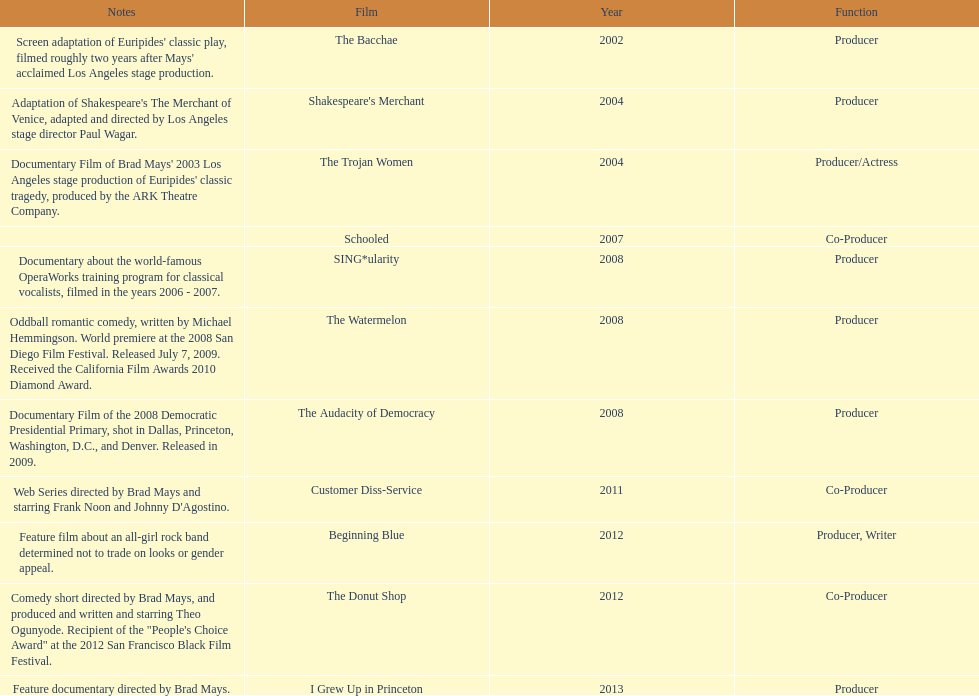In which year did ms. starfelt produce the most films? 2008. 